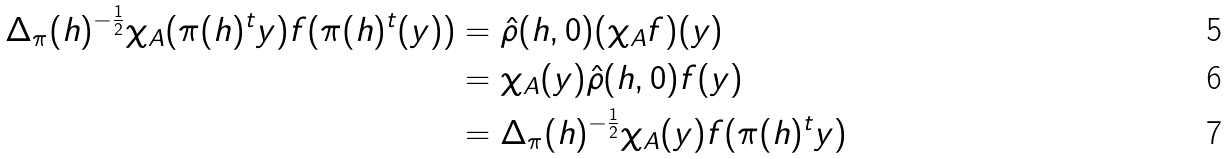<formula> <loc_0><loc_0><loc_500><loc_500>\Delta _ { \pi } ( h ) ^ { - \frac { 1 } { 2 } } \chi _ { A } ( \pi ( h ) ^ { t } y ) f ( \pi ( h ) ^ { t } ( y ) ) & = \hat { \rho } ( h , 0 ) ( \chi _ { A } f ) ( y ) \\ & = \chi _ { A } ( y ) \hat { \rho } ( h , 0 ) f ( y ) \\ & = \Delta _ { \pi } ( h ) ^ { - \frac { 1 } { 2 } } \chi _ { A } ( y ) f ( \pi ( h ) ^ { t } y )</formula> 